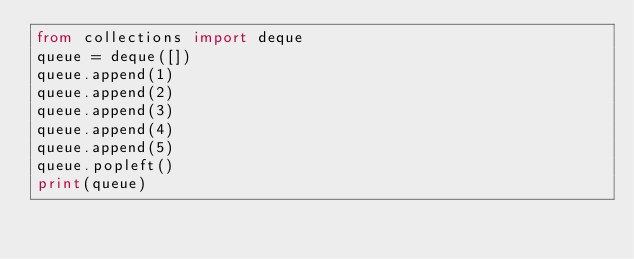Convert code to text. <code><loc_0><loc_0><loc_500><loc_500><_Python_>from collections import deque
queue = deque([])
queue.append(1)
queue.append(2)
queue.append(3)
queue.append(4)
queue.append(5)
queue.popleft()
print(queue)
</code> 